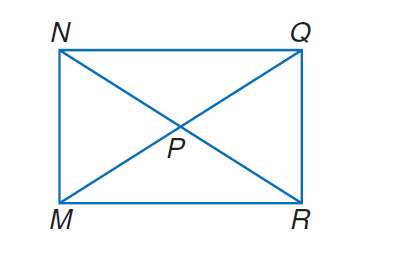Question: M N Q R is a rectangle. If N R = 2 x + 10 and N P = 2 x - 30, find M P.
Choices:
A. 10
B. 20
C. 30
D. 40
Answer with the letter. Answer: D 